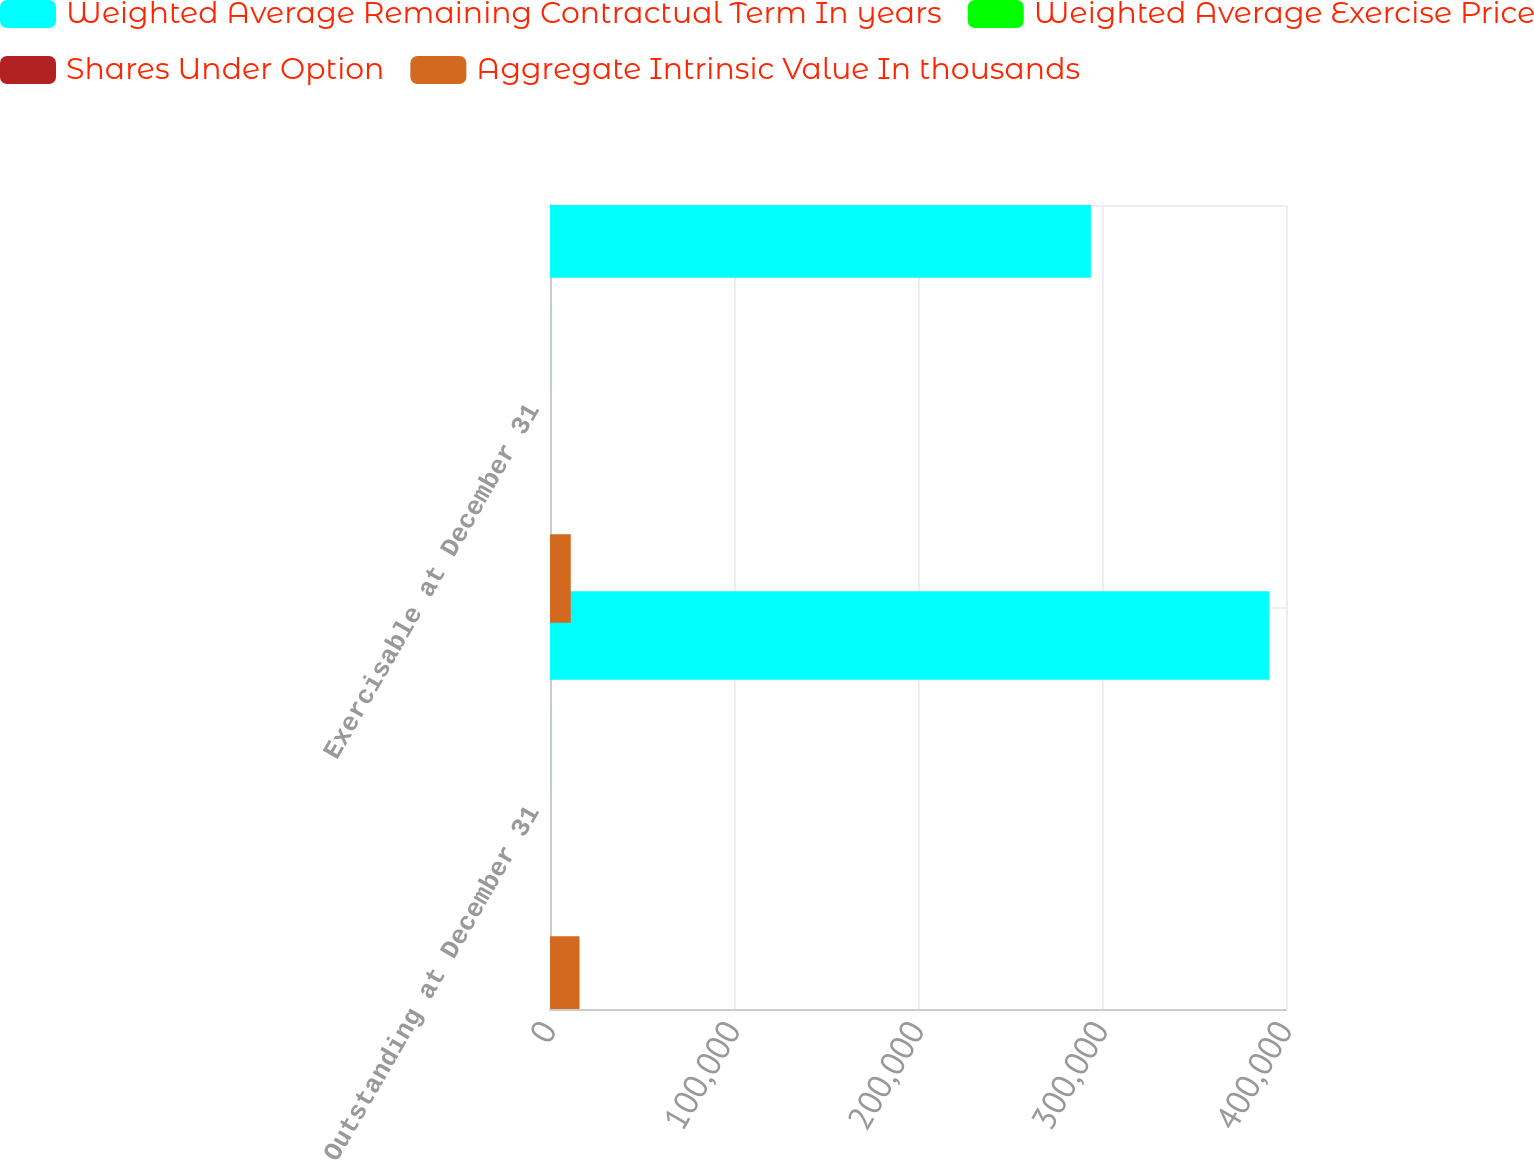Convert chart. <chart><loc_0><loc_0><loc_500><loc_500><stacked_bar_chart><ecel><fcel>Outstanding at December 31<fcel>Exercisable at December 31<nl><fcel>Weighted Average Remaining Contractual Term In years<fcel>390889<fcel>293946<nl><fcel>Weighted Average Exercise Price<fcel>62.96<fcel>65.66<nl><fcel>Shares Under Option<fcel>5.2<fcel>5<nl><fcel>Aggregate Intrinsic Value In thousands<fcel>16048<fcel>11276<nl></chart> 